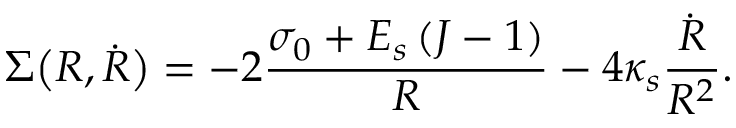<formula> <loc_0><loc_0><loc_500><loc_500>\Sigma \left ( R , \dot { R } \right ) = - 2 \frac { \sigma _ { 0 } + E _ { s } \left ( J - 1 \right ) } { R } - 4 \kappa _ { s } \frac { \dot { R } } { R ^ { 2 } } .</formula> 